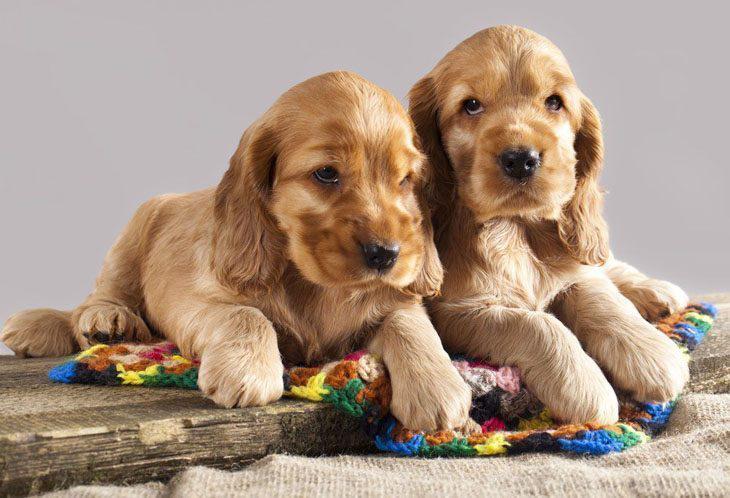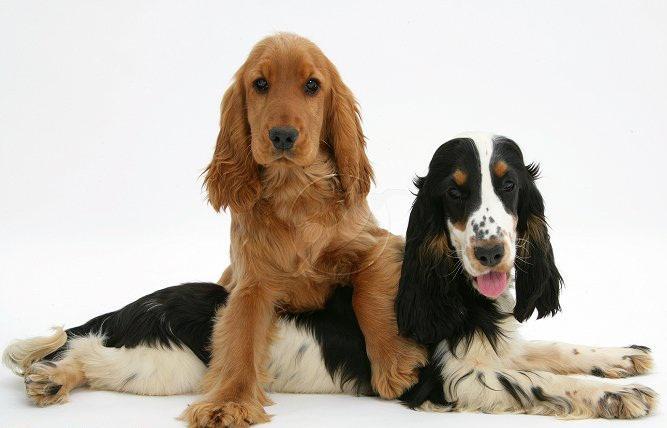The first image is the image on the left, the second image is the image on the right. Given the left and right images, does the statement "Every image shoes exactly three dogs, where in one image all three dogs are blond colored and the other image they have varying colors." hold true? Answer yes or no. No. The first image is the image on the left, the second image is the image on the right. Given the left and right images, does the statement "There is exactly three dogs in the left image." hold true? Answer yes or no. No. 